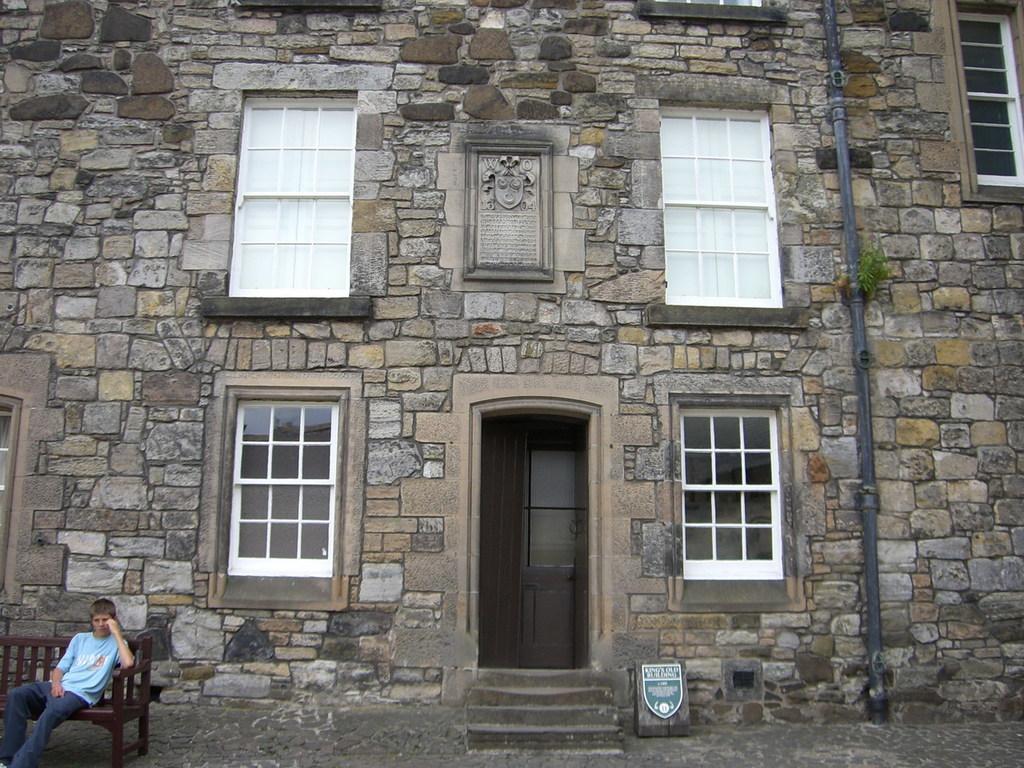Can you describe this image briefly? In this image I can see a building. It has door and windows. There is a pipe on the right. A person is sitting on a bench, on the left. 